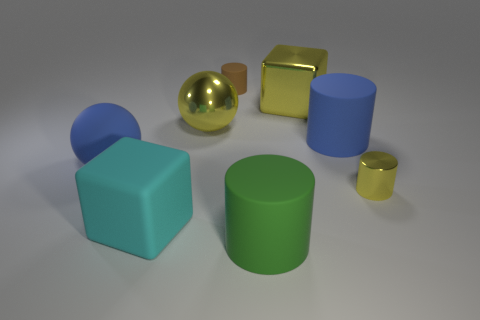Subtract all tiny brown cylinders. How many cylinders are left? 3 Subtract all green cylinders. How many cylinders are left? 3 Add 2 big green things. How many objects exist? 10 Subtract 1 spheres. How many spheres are left? 1 Add 7 tiny metal things. How many tiny metal things are left? 8 Add 6 large rubber spheres. How many large rubber spheres exist? 7 Subtract 1 blue cylinders. How many objects are left? 7 Subtract all cubes. How many objects are left? 6 Subtract all yellow cubes. Subtract all blue cylinders. How many cubes are left? 1 Subtract all red cylinders. How many yellow balls are left? 1 